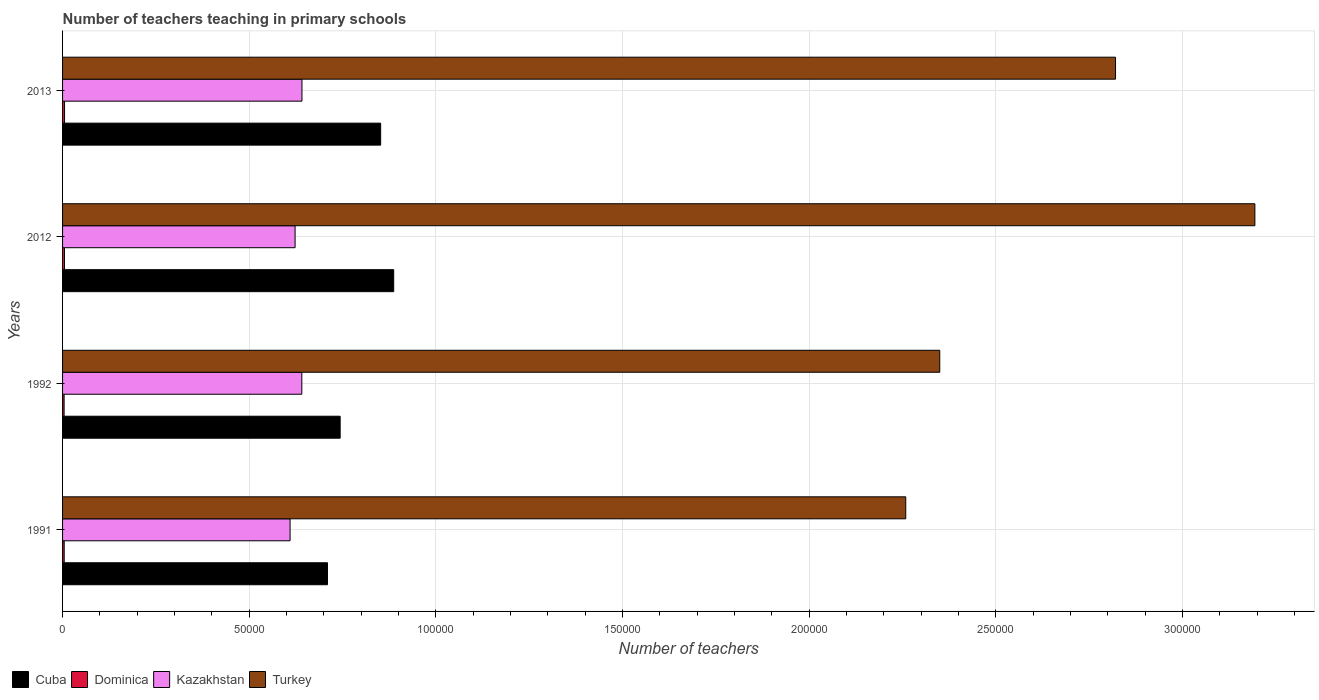How many bars are there on the 3rd tick from the bottom?
Give a very brief answer. 4. What is the number of teachers teaching in primary schools in Cuba in 1992?
Make the answer very short. 7.44e+04. Across all years, what is the maximum number of teachers teaching in primary schools in Kazakhstan?
Provide a succinct answer. 6.41e+04. Across all years, what is the minimum number of teachers teaching in primary schools in Kazakhstan?
Your answer should be compact. 6.09e+04. In which year was the number of teachers teaching in primary schools in Dominica minimum?
Offer a terse response. 1992. What is the total number of teachers teaching in primary schools in Dominica in the graph?
Make the answer very short. 1898. What is the difference between the number of teachers teaching in primary schools in Turkey in 1991 and that in 2013?
Provide a short and direct response. -5.62e+04. What is the difference between the number of teachers teaching in primary schools in Turkey in 1991 and the number of teachers teaching in primary schools in Cuba in 2013?
Ensure brevity in your answer.  1.41e+05. What is the average number of teachers teaching in primary schools in Cuba per year?
Offer a terse response. 7.98e+04. In the year 1991, what is the difference between the number of teachers teaching in primary schools in Turkey and number of teachers teaching in primary schools in Dominica?
Give a very brief answer. 2.25e+05. What is the ratio of the number of teachers teaching in primary schools in Dominica in 1992 to that in 2013?
Make the answer very short. 0.78. Is the number of teachers teaching in primary schools in Kazakhstan in 1992 less than that in 2013?
Provide a succinct answer. Yes. What is the difference between the highest and the second highest number of teachers teaching in primary schools in Turkey?
Your answer should be very brief. 3.73e+04. What is the difference between the highest and the lowest number of teachers teaching in primary schools in Dominica?
Make the answer very short. 115. In how many years, is the number of teachers teaching in primary schools in Turkey greater than the average number of teachers teaching in primary schools in Turkey taken over all years?
Your answer should be very brief. 2. Is it the case that in every year, the sum of the number of teachers teaching in primary schools in Dominica and number of teachers teaching in primary schools in Turkey is greater than the sum of number of teachers teaching in primary schools in Cuba and number of teachers teaching in primary schools in Kazakhstan?
Make the answer very short. Yes. What does the 2nd bar from the top in 2012 represents?
Give a very brief answer. Kazakhstan. What does the 3rd bar from the bottom in 2012 represents?
Offer a terse response. Kazakhstan. Are the values on the major ticks of X-axis written in scientific E-notation?
Provide a succinct answer. No. Does the graph contain grids?
Keep it short and to the point. Yes. What is the title of the graph?
Provide a succinct answer. Number of teachers teaching in primary schools. Does "Central Europe" appear as one of the legend labels in the graph?
Offer a very short reply. No. What is the label or title of the X-axis?
Give a very brief answer. Number of teachers. What is the Number of teachers in Cuba in 1991?
Offer a very short reply. 7.10e+04. What is the Number of teachers of Dominica in 1991?
Provide a short and direct response. 439. What is the Number of teachers of Kazakhstan in 1991?
Your answer should be compact. 6.09e+04. What is the Number of teachers in Turkey in 1991?
Give a very brief answer. 2.26e+05. What is the Number of teachers in Cuba in 1992?
Your answer should be very brief. 7.44e+04. What is the Number of teachers in Dominica in 1992?
Give a very brief answer. 414. What is the Number of teachers in Kazakhstan in 1992?
Your response must be concise. 6.41e+04. What is the Number of teachers in Turkey in 1992?
Your answer should be very brief. 2.35e+05. What is the Number of teachers of Cuba in 2012?
Keep it short and to the point. 8.87e+04. What is the Number of teachers of Dominica in 2012?
Provide a succinct answer. 516. What is the Number of teachers in Kazakhstan in 2012?
Offer a very short reply. 6.23e+04. What is the Number of teachers in Turkey in 2012?
Give a very brief answer. 3.19e+05. What is the Number of teachers in Cuba in 2013?
Your answer should be compact. 8.52e+04. What is the Number of teachers of Dominica in 2013?
Your answer should be very brief. 529. What is the Number of teachers in Kazakhstan in 2013?
Give a very brief answer. 6.41e+04. What is the Number of teachers in Turkey in 2013?
Make the answer very short. 2.82e+05. Across all years, what is the maximum Number of teachers in Cuba?
Provide a succinct answer. 8.87e+04. Across all years, what is the maximum Number of teachers of Dominica?
Your response must be concise. 529. Across all years, what is the maximum Number of teachers of Kazakhstan?
Keep it short and to the point. 6.41e+04. Across all years, what is the maximum Number of teachers in Turkey?
Provide a succinct answer. 3.19e+05. Across all years, what is the minimum Number of teachers of Cuba?
Provide a short and direct response. 7.10e+04. Across all years, what is the minimum Number of teachers of Dominica?
Offer a terse response. 414. Across all years, what is the minimum Number of teachers in Kazakhstan?
Make the answer very short. 6.09e+04. Across all years, what is the minimum Number of teachers in Turkey?
Offer a very short reply. 2.26e+05. What is the total Number of teachers in Cuba in the graph?
Give a very brief answer. 3.19e+05. What is the total Number of teachers of Dominica in the graph?
Your response must be concise. 1898. What is the total Number of teachers in Kazakhstan in the graph?
Make the answer very short. 2.51e+05. What is the total Number of teachers in Turkey in the graph?
Ensure brevity in your answer.  1.06e+06. What is the difference between the Number of teachers in Cuba in 1991 and that in 1992?
Provide a succinct answer. -3392. What is the difference between the Number of teachers of Kazakhstan in 1991 and that in 1992?
Offer a very short reply. -3147. What is the difference between the Number of teachers in Turkey in 1991 and that in 1992?
Offer a very short reply. -9109. What is the difference between the Number of teachers in Cuba in 1991 and that in 2012?
Provide a short and direct response. -1.77e+04. What is the difference between the Number of teachers in Dominica in 1991 and that in 2012?
Provide a succinct answer. -77. What is the difference between the Number of teachers of Kazakhstan in 1991 and that in 2012?
Make the answer very short. -1343. What is the difference between the Number of teachers of Turkey in 1991 and that in 2012?
Provide a short and direct response. -9.35e+04. What is the difference between the Number of teachers in Cuba in 1991 and that in 2013?
Offer a terse response. -1.42e+04. What is the difference between the Number of teachers in Dominica in 1991 and that in 2013?
Your response must be concise. -90. What is the difference between the Number of teachers of Kazakhstan in 1991 and that in 2013?
Give a very brief answer. -3182. What is the difference between the Number of teachers of Turkey in 1991 and that in 2013?
Keep it short and to the point. -5.62e+04. What is the difference between the Number of teachers in Cuba in 1992 and that in 2012?
Your answer should be compact. -1.43e+04. What is the difference between the Number of teachers of Dominica in 1992 and that in 2012?
Your response must be concise. -102. What is the difference between the Number of teachers of Kazakhstan in 1992 and that in 2012?
Keep it short and to the point. 1804. What is the difference between the Number of teachers in Turkey in 1992 and that in 2012?
Your response must be concise. -8.44e+04. What is the difference between the Number of teachers in Cuba in 1992 and that in 2013?
Make the answer very short. -1.08e+04. What is the difference between the Number of teachers in Dominica in 1992 and that in 2013?
Make the answer very short. -115. What is the difference between the Number of teachers in Kazakhstan in 1992 and that in 2013?
Make the answer very short. -35. What is the difference between the Number of teachers of Turkey in 1992 and that in 2013?
Offer a terse response. -4.71e+04. What is the difference between the Number of teachers in Cuba in 2012 and that in 2013?
Keep it short and to the point. 3497. What is the difference between the Number of teachers in Kazakhstan in 2012 and that in 2013?
Provide a short and direct response. -1839. What is the difference between the Number of teachers of Turkey in 2012 and that in 2013?
Your response must be concise. 3.73e+04. What is the difference between the Number of teachers of Cuba in 1991 and the Number of teachers of Dominica in 1992?
Make the answer very short. 7.05e+04. What is the difference between the Number of teachers of Cuba in 1991 and the Number of teachers of Kazakhstan in 1992?
Make the answer very short. 6873. What is the difference between the Number of teachers in Cuba in 1991 and the Number of teachers in Turkey in 1992?
Provide a succinct answer. -1.64e+05. What is the difference between the Number of teachers in Dominica in 1991 and the Number of teachers in Kazakhstan in 1992?
Ensure brevity in your answer.  -6.36e+04. What is the difference between the Number of teachers of Dominica in 1991 and the Number of teachers of Turkey in 1992?
Your answer should be compact. -2.35e+05. What is the difference between the Number of teachers in Kazakhstan in 1991 and the Number of teachers in Turkey in 1992?
Offer a terse response. -1.74e+05. What is the difference between the Number of teachers of Cuba in 1991 and the Number of teachers of Dominica in 2012?
Give a very brief answer. 7.04e+04. What is the difference between the Number of teachers in Cuba in 1991 and the Number of teachers in Kazakhstan in 2012?
Your response must be concise. 8677. What is the difference between the Number of teachers in Cuba in 1991 and the Number of teachers in Turkey in 2012?
Your response must be concise. -2.48e+05. What is the difference between the Number of teachers of Dominica in 1991 and the Number of teachers of Kazakhstan in 2012?
Your response must be concise. -6.18e+04. What is the difference between the Number of teachers in Dominica in 1991 and the Number of teachers in Turkey in 2012?
Provide a short and direct response. -3.19e+05. What is the difference between the Number of teachers in Kazakhstan in 1991 and the Number of teachers in Turkey in 2012?
Ensure brevity in your answer.  -2.58e+05. What is the difference between the Number of teachers of Cuba in 1991 and the Number of teachers of Dominica in 2013?
Ensure brevity in your answer.  7.04e+04. What is the difference between the Number of teachers in Cuba in 1991 and the Number of teachers in Kazakhstan in 2013?
Offer a terse response. 6838. What is the difference between the Number of teachers in Cuba in 1991 and the Number of teachers in Turkey in 2013?
Offer a very short reply. -2.11e+05. What is the difference between the Number of teachers in Dominica in 1991 and the Number of teachers in Kazakhstan in 2013?
Provide a short and direct response. -6.37e+04. What is the difference between the Number of teachers in Dominica in 1991 and the Number of teachers in Turkey in 2013?
Your answer should be compact. -2.82e+05. What is the difference between the Number of teachers of Kazakhstan in 1991 and the Number of teachers of Turkey in 2013?
Provide a succinct answer. -2.21e+05. What is the difference between the Number of teachers of Cuba in 1992 and the Number of teachers of Dominica in 2012?
Offer a terse response. 7.38e+04. What is the difference between the Number of teachers in Cuba in 1992 and the Number of teachers in Kazakhstan in 2012?
Make the answer very short. 1.21e+04. What is the difference between the Number of teachers in Cuba in 1992 and the Number of teachers in Turkey in 2012?
Provide a short and direct response. -2.45e+05. What is the difference between the Number of teachers of Dominica in 1992 and the Number of teachers of Kazakhstan in 2012?
Make the answer very short. -6.19e+04. What is the difference between the Number of teachers of Dominica in 1992 and the Number of teachers of Turkey in 2012?
Offer a very short reply. -3.19e+05. What is the difference between the Number of teachers in Kazakhstan in 1992 and the Number of teachers in Turkey in 2012?
Ensure brevity in your answer.  -2.55e+05. What is the difference between the Number of teachers in Cuba in 1992 and the Number of teachers in Dominica in 2013?
Make the answer very short. 7.38e+04. What is the difference between the Number of teachers of Cuba in 1992 and the Number of teachers of Kazakhstan in 2013?
Ensure brevity in your answer.  1.02e+04. What is the difference between the Number of teachers of Cuba in 1992 and the Number of teachers of Turkey in 2013?
Your response must be concise. -2.08e+05. What is the difference between the Number of teachers in Dominica in 1992 and the Number of teachers in Kazakhstan in 2013?
Offer a terse response. -6.37e+04. What is the difference between the Number of teachers of Dominica in 1992 and the Number of teachers of Turkey in 2013?
Make the answer very short. -2.82e+05. What is the difference between the Number of teachers in Kazakhstan in 1992 and the Number of teachers in Turkey in 2013?
Your answer should be compact. -2.18e+05. What is the difference between the Number of teachers in Cuba in 2012 and the Number of teachers in Dominica in 2013?
Ensure brevity in your answer.  8.82e+04. What is the difference between the Number of teachers of Cuba in 2012 and the Number of teachers of Kazakhstan in 2013?
Provide a short and direct response. 2.46e+04. What is the difference between the Number of teachers of Cuba in 2012 and the Number of teachers of Turkey in 2013?
Your response must be concise. -1.93e+05. What is the difference between the Number of teachers of Dominica in 2012 and the Number of teachers of Kazakhstan in 2013?
Keep it short and to the point. -6.36e+04. What is the difference between the Number of teachers of Dominica in 2012 and the Number of teachers of Turkey in 2013?
Ensure brevity in your answer.  -2.82e+05. What is the difference between the Number of teachers of Kazakhstan in 2012 and the Number of teachers of Turkey in 2013?
Your answer should be compact. -2.20e+05. What is the average Number of teachers in Cuba per year?
Your response must be concise. 7.98e+04. What is the average Number of teachers in Dominica per year?
Your response must be concise. 474.5. What is the average Number of teachers of Kazakhstan per year?
Offer a terse response. 6.29e+04. What is the average Number of teachers in Turkey per year?
Ensure brevity in your answer.  2.66e+05. In the year 1991, what is the difference between the Number of teachers in Cuba and Number of teachers in Dominica?
Provide a succinct answer. 7.05e+04. In the year 1991, what is the difference between the Number of teachers of Cuba and Number of teachers of Kazakhstan?
Make the answer very short. 1.00e+04. In the year 1991, what is the difference between the Number of teachers in Cuba and Number of teachers in Turkey?
Provide a short and direct response. -1.55e+05. In the year 1991, what is the difference between the Number of teachers of Dominica and Number of teachers of Kazakhstan?
Keep it short and to the point. -6.05e+04. In the year 1991, what is the difference between the Number of teachers in Dominica and Number of teachers in Turkey?
Offer a very short reply. -2.25e+05. In the year 1991, what is the difference between the Number of teachers in Kazakhstan and Number of teachers in Turkey?
Offer a very short reply. -1.65e+05. In the year 1992, what is the difference between the Number of teachers in Cuba and Number of teachers in Dominica?
Ensure brevity in your answer.  7.39e+04. In the year 1992, what is the difference between the Number of teachers of Cuba and Number of teachers of Kazakhstan?
Make the answer very short. 1.03e+04. In the year 1992, what is the difference between the Number of teachers of Cuba and Number of teachers of Turkey?
Give a very brief answer. -1.61e+05. In the year 1992, what is the difference between the Number of teachers of Dominica and Number of teachers of Kazakhstan?
Offer a terse response. -6.37e+04. In the year 1992, what is the difference between the Number of teachers in Dominica and Number of teachers in Turkey?
Make the answer very short. -2.35e+05. In the year 1992, what is the difference between the Number of teachers in Kazakhstan and Number of teachers in Turkey?
Your answer should be compact. -1.71e+05. In the year 2012, what is the difference between the Number of teachers in Cuba and Number of teachers in Dominica?
Your response must be concise. 8.82e+04. In the year 2012, what is the difference between the Number of teachers of Cuba and Number of teachers of Kazakhstan?
Your answer should be very brief. 2.64e+04. In the year 2012, what is the difference between the Number of teachers in Cuba and Number of teachers in Turkey?
Provide a short and direct response. -2.31e+05. In the year 2012, what is the difference between the Number of teachers of Dominica and Number of teachers of Kazakhstan?
Provide a succinct answer. -6.18e+04. In the year 2012, what is the difference between the Number of teachers in Dominica and Number of teachers in Turkey?
Your response must be concise. -3.19e+05. In the year 2012, what is the difference between the Number of teachers of Kazakhstan and Number of teachers of Turkey?
Offer a terse response. -2.57e+05. In the year 2013, what is the difference between the Number of teachers in Cuba and Number of teachers in Dominica?
Offer a terse response. 8.47e+04. In the year 2013, what is the difference between the Number of teachers in Cuba and Number of teachers in Kazakhstan?
Your answer should be very brief. 2.11e+04. In the year 2013, what is the difference between the Number of teachers in Cuba and Number of teachers in Turkey?
Make the answer very short. -1.97e+05. In the year 2013, what is the difference between the Number of teachers of Dominica and Number of teachers of Kazakhstan?
Give a very brief answer. -6.36e+04. In the year 2013, what is the difference between the Number of teachers in Dominica and Number of teachers in Turkey?
Your answer should be very brief. -2.82e+05. In the year 2013, what is the difference between the Number of teachers of Kazakhstan and Number of teachers of Turkey?
Offer a very short reply. -2.18e+05. What is the ratio of the Number of teachers of Cuba in 1991 to that in 1992?
Ensure brevity in your answer.  0.95. What is the ratio of the Number of teachers in Dominica in 1991 to that in 1992?
Keep it short and to the point. 1.06. What is the ratio of the Number of teachers of Kazakhstan in 1991 to that in 1992?
Offer a terse response. 0.95. What is the ratio of the Number of teachers in Turkey in 1991 to that in 1992?
Keep it short and to the point. 0.96. What is the ratio of the Number of teachers of Cuba in 1991 to that in 2012?
Make the answer very short. 0.8. What is the ratio of the Number of teachers of Dominica in 1991 to that in 2012?
Make the answer very short. 0.85. What is the ratio of the Number of teachers in Kazakhstan in 1991 to that in 2012?
Make the answer very short. 0.98. What is the ratio of the Number of teachers in Turkey in 1991 to that in 2012?
Ensure brevity in your answer.  0.71. What is the ratio of the Number of teachers in Cuba in 1991 to that in 2013?
Offer a very short reply. 0.83. What is the ratio of the Number of teachers in Dominica in 1991 to that in 2013?
Provide a succinct answer. 0.83. What is the ratio of the Number of teachers of Kazakhstan in 1991 to that in 2013?
Keep it short and to the point. 0.95. What is the ratio of the Number of teachers of Turkey in 1991 to that in 2013?
Offer a very short reply. 0.8. What is the ratio of the Number of teachers of Cuba in 1992 to that in 2012?
Keep it short and to the point. 0.84. What is the ratio of the Number of teachers of Dominica in 1992 to that in 2012?
Your response must be concise. 0.8. What is the ratio of the Number of teachers of Kazakhstan in 1992 to that in 2012?
Provide a succinct answer. 1.03. What is the ratio of the Number of teachers of Turkey in 1992 to that in 2012?
Provide a succinct answer. 0.74. What is the ratio of the Number of teachers in Cuba in 1992 to that in 2013?
Offer a very short reply. 0.87. What is the ratio of the Number of teachers in Dominica in 1992 to that in 2013?
Give a very brief answer. 0.78. What is the ratio of the Number of teachers of Turkey in 1992 to that in 2013?
Give a very brief answer. 0.83. What is the ratio of the Number of teachers of Cuba in 2012 to that in 2013?
Make the answer very short. 1.04. What is the ratio of the Number of teachers in Dominica in 2012 to that in 2013?
Your response must be concise. 0.98. What is the ratio of the Number of teachers in Kazakhstan in 2012 to that in 2013?
Your answer should be compact. 0.97. What is the ratio of the Number of teachers in Turkey in 2012 to that in 2013?
Your answer should be compact. 1.13. What is the difference between the highest and the second highest Number of teachers in Cuba?
Offer a terse response. 3497. What is the difference between the highest and the second highest Number of teachers of Dominica?
Your response must be concise. 13. What is the difference between the highest and the second highest Number of teachers of Kazakhstan?
Give a very brief answer. 35. What is the difference between the highest and the second highest Number of teachers in Turkey?
Your answer should be compact. 3.73e+04. What is the difference between the highest and the lowest Number of teachers in Cuba?
Offer a very short reply. 1.77e+04. What is the difference between the highest and the lowest Number of teachers of Dominica?
Your answer should be compact. 115. What is the difference between the highest and the lowest Number of teachers in Kazakhstan?
Make the answer very short. 3182. What is the difference between the highest and the lowest Number of teachers of Turkey?
Provide a short and direct response. 9.35e+04. 